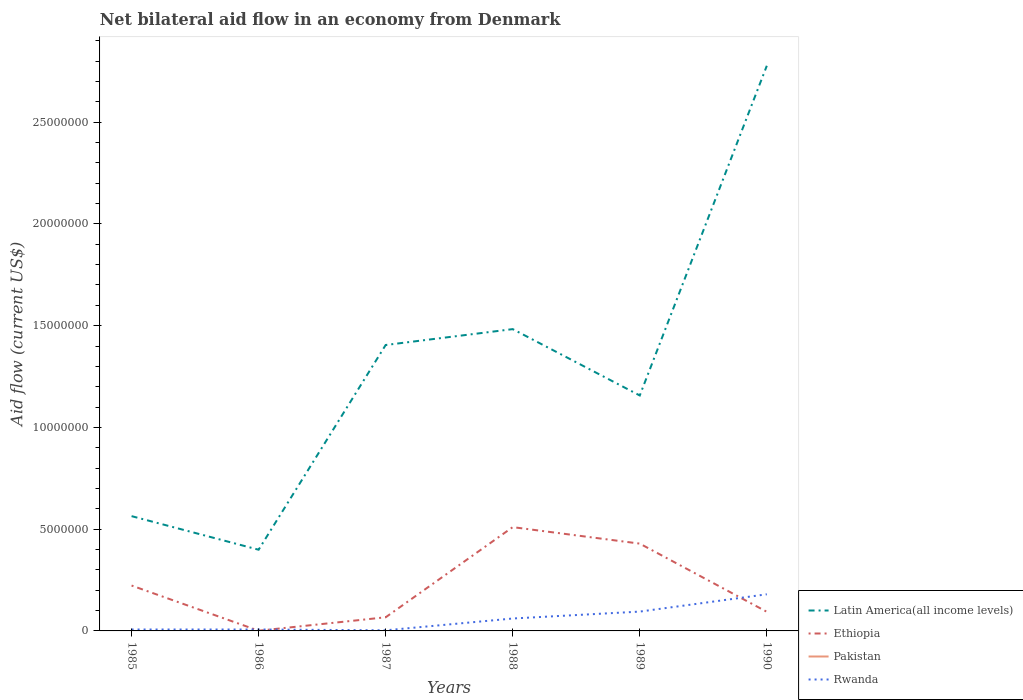How many different coloured lines are there?
Give a very brief answer. 3. Does the line corresponding to Pakistan intersect with the line corresponding to Latin America(all income levels)?
Your answer should be very brief. No. Is the number of lines equal to the number of legend labels?
Provide a short and direct response. No. Across all years, what is the maximum net bilateral aid flow in Pakistan?
Your response must be concise. 0. What is the total net bilateral aid flow in Latin America(all income levels) in the graph?
Provide a short and direct response. -1.29e+07. What is the difference between the highest and the second highest net bilateral aid flow in Rwanda?
Your answer should be compact. 1.77e+06. What is the difference between the highest and the lowest net bilateral aid flow in Rwanda?
Offer a terse response. 3. How many years are there in the graph?
Your answer should be compact. 6. Are the values on the major ticks of Y-axis written in scientific E-notation?
Offer a terse response. No. How are the legend labels stacked?
Make the answer very short. Vertical. What is the title of the graph?
Your response must be concise. Net bilateral aid flow in an economy from Denmark. Does "St. Lucia" appear as one of the legend labels in the graph?
Ensure brevity in your answer.  No. What is the Aid flow (current US$) of Latin America(all income levels) in 1985?
Make the answer very short. 5.64e+06. What is the Aid flow (current US$) in Ethiopia in 1985?
Your response must be concise. 2.23e+06. What is the Aid flow (current US$) of Rwanda in 1985?
Your response must be concise. 7.00e+04. What is the Aid flow (current US$) of Latin America(all income levels) in 1986?
Provide a succinct answer. 3.99e+06. What is the Aid flow (current US$) of Ethiopia in 1986?
Provide a short and direct response. 10000. What is the Aid flow (current US$) in Pakistan in 1986?
Offer a terse response. 0. What is the Aid flow (current US$) in Rwanda in 1986?
Keep it short and to the point. 7.00e+04. What is the Aid flow (current US$) of Latin America(all income levels) in 1987?
Offer a terse response. 1.40e+07. What is the Aid flow (current US$) in Ethiopia in 1987?
Provide a short and direct response. 6.70e+05. What is the Aid flow (current US$) of Rwanda in 1987?
Give a very brief answer. 3.00e+04. What is the Aid flow (current US$) of Latin America(all income levels) in 1988?
Your response must be concise. 1.48e+07. What is the Aid flow (current US$) in Ethiopia in 1988?
Offer a very short reply. 5.10e+06. What is the Aid flow (current US$) in Latin America(all income levels) in 1989?
Make the answer very short. 1.16e+07. What is the Aid flow (current US$) in Ethiopia in 1989?
Provide a short and direct response. 4.29e+06. What is the Aid flow (current US$) of Pakistan in 1989?
Provide a short and direct response. 0. What is the Aid flow (current US$) in Rwanda in 1989?
Offer a terse response. 9.50e+05. What is the Aid flow (current US$) of Latin America(all income levels) in 1990?
Make the answer very short. 2.78e+07. What is the Aid flow (current US$) of Ethiopia in 1990?
Keep it short and to the point. 9.40e+05. What is the Aid flow (current US$) of Pakistan in 1990?
Offer a very short reply. 0. What is the Aid flow (current US$) in Rwanda in 1990?
Your answer should be compact. 1.80e+06. Across all years, what is the maximum Aid flow (current US$) of Latin America(all income levels)?
Keep it short and to the point. 2.78e+07. Across all years, what is the maximum Aid flow (current US$) of Ethiopia?
Provide a succinct answer. 5.10e+06. Across all years, what is the maximum Aid flow (current US$) of Rwanda?
Give a very brief answer. 1.80e+06. Across all years, what is the minimum Aid flow (current US$) of Latin America(all income levels)?
Give a very brief answer. 3.99e+06. Across all years, what is the minimum Aid flow (current US$) in Ethiopia?
Make the answer very short. 10000. What is the total Aid flow (current US$) in Latin America(all income levels) in the graph?
Your response must be concise. 7.78e+07. What is the total Aid flow (current US$) of Ethiopia in the graph?
Make the answer very short. 1.32e+07. What is the total Aid flow (current US$) of Pakistan in the graph?
Offer a very short reply. 0. What is the total Aid flow (current US$) in Rwanda in the graph?
Keep it short and to the point. 3.53e+06. What is the difference between the Aid flow (current US$) of Latin America(all income levels) in 1985 and that in 1986?
Ensure brevity in your answer.  1.65e+06. What is the difference between the Aid flow (current US$) of Ethiopia in 1985 and that in 1986?
Keep it short and to the point. 2.22e+06. What is the difference between the Aid flow (current US$) in Rwanda in 1985 and that in 1986?
Provide a succinct answer. 0. What is the difference between the Aid flow (current US$) in Latin America(all income levels) in 1985 and that in 1987?
Your answer should be compact. -8.41e+06. What is the difference between the Aid flow (current US$) in Ethiopia in 1985 and that in 1987?
Your response must be concise. 1.56e+06. What is the difference between the Aid flow (current US$) in Rwanda in 1985 and that in 1987?
Your response must be concise. 4.00e+04. What is the difference between the Aid flow (current US$) of Latin America(all income levels) in 1985 and that in 1988?
Your answer should be compact. -9.19e+06. What is the difference between the Aid flow (current US$) in Ethiopia in 1985 and that in 1988?
Give a very brief answer. -2.87e+06. What is the difference between the Aid flow (current US$) in Rwanda in 1985 and that in 1988?
Make the answer very short. -5.40e+05. What is the difference between the Aid flow (current US$) in Latin America(all income levels) in 1985 and that in 1989?
Provide a short and direct response. -5.93e+06. What is the difference between the Aid flow (current US$) of Ethiopia in 1985 and that in 1989?
Your response must be concise. -2.06e+06. What is the difference between the Aid flow (current US$) of Rwanda in 1985 and that in 1989?
Ensure brevity in your answer.  -8.80e+05. What is the difference between the Aid flow (current US$) in Latin America(all income levels) in 1985 and that in 1990?
Provide a short and direct response. -2.21e+07. What is the difference between the Aid flow (current US$) in Ethiopia in 1985 and that in 1990?
Your answer should be very brief. 1.29e+06. What is the difference between the Aid flow (current US$) of Rwanda in 1985 and that in 1990?
Offer a terse response. -1.73e+06. What is the difference between the Aid flow (current US$) in Latin America(all income levels) in 1986 and that in 1987?
Make the answer very short. -1.01e+07. What is the difference between the Aid flow (current US$) of Ethiopia in 1986 and that in 1987?
Offer a very short reply. -6.60e+05. What is the difference between the Aid flow (current US$) of Latin America(all income levels) in 1986 and that in 1988?
Provide a succinct answer. -1.08e+07. What is the difference between the Aid flow (current US$) in Ethiopia in 1986 and that in 1988?
Provide a succinct answer. -5.09e+06. What is the difference between the Aid flow (current US$) of Rwanda in 1986 and that in 1988?
Your answer should be very brief. -5.40e+05. What is the difference between the Aid flow (current US$) in Latin America(all income levels) in 1986 and that in 1989?
Make the answer very short. -7.58e+06. What is the difference between the Aid flow (current US$) of Ethiopia in 1986 and that in 1989?
Make the answer very short. -4.28e+06. What is the difference between the Aid flow (current US$) in Rwanda in 1986 and that in 1989?
Keep it short and to the point. -8.80e+05. What is the difference between the Aid flow (current US$) of Latin America(all income levels) in 1986 and that in 1990?
Your answer should be very brief. -2.38e+07. What is the difference between the Aid flow (current US$) in Ethiopia in 1986 and that in 1990?
Your answer should be very brief. -9.30e+05. What is the difference between the Aid flow (current US$) in Rwanda in 1986 and that in 1990?
Give a very brief answer. -1.73e+06. What is the difference between the Aid flow (current US$) in Latin America(all income levels) in 1987 and that in 1988?
Offer a very short reply. -7.80e+05. What is the difference between the Aid flow (current US$) of Ethiopia in 1987 and that in 1988?
Keep it short and to the point. -4.43e+06. What is the difference between the Aid flow (current US$) in Rwanda in 1987 and that in 1988?
Your response must be concise. -5.80e+05. What is the difference between the Aid flow (current US$) of Latin America(all income levels) in 1987 and that in 1989?
Your answer should be very brief. 2.48e+06. What is the difference between the Aid flow (current US$) in Ethiopia in 1987 and that in 1989?
Keep it short and to the point. -3.62e+06. What is the difference between the Aid flow (current US$) of Rwanda in 1987 and that in 1989?
Your answer should be compact. -9.20e+05. What is the difference between the Aid flow (current US$) of Latin America(all income levels) in 1987 and that in 1990?
Provide a succinct answer. -1.37e+07. What is the difference between the Aid flow (current US$) in Rwanda in 1987 and that in 1990?
Make the answer very short. -1.77e+06. What is the difference between the Aid flow (current US$) in Latin America(all income levels) in 1988 and that in 1989?
Your answer should be very brief. 3.26e+06. What is the difference between the Aid flow (current US$) of Ethiopia in 1988 and that in 1989?
Provide a short and direct response. 8.10e+05. What is the difference between the Aid flow (current US$) of Latin America(all income levels) in 1988 and that in 1990?
Ensure brevity in your answer.  -1.29e+07. What is the difference between the Aid flow (current US$) in Ethiopia in 1988 and that in 1990?
Provide a succinct answer. 4.16e+06. What is the difference between the Aid flow (current US$) of Rwanda in 1988 and that in 1990?
Keep it short and to the point. -1.19e+06. What is the difference between the Aid flow (current US$) in Latin America(all income levels) in 1989 and that in 1990?
Keep it short and to the point. -1.62e+07. What is the difference between the Aid flow (current US$) in Ethiopia in 1989 and that in 1990?
Your answer should be compact. 3.35e+06. What is the difference between the Aid flow (current US$) in Rwanda in 1989 and that in 1990?
Make the answer very short. -8.50e+05. What is the difference between the Aid flow (current US$) of Latin America(all income levels) in 1985 and the Aid flow (current US$) of Ethiopia in 1986?
Make the answer very short. 5.63e+06. What is the difference between the Aid flow (current US$) of Latin America(all income levels) in 1985 and the Aid flow (current US$) of Rwanda in 1986?
Your answer should be compact. 5.57e+06. What is the difference between the Aid flow (current US$) of Ethiopia in 1985 and the Aid flow (current US$) of Rwanda in 1986?
Provide a succinct answer. 2.16e+06. What is the difference between the Aid flow (current US$) of Latin America(all income levels) in 1985 and the Aid flow (current US$) of Ethiopia in 1987?
Offer a very short reply. 4.97e+06. What is the difference between the Aid flow (current US$) in Latin America(all income levels) in 1985 and the Aid flow (current US$) in Rwanda in 1987?
Your answer should be very brief. 5.61e+06. What is the difference between the Aid flow (current US$) in Ethiopia in 1985 and the Aid flow (current US$) in Rwanda in 1987?
Offer a terse response. 2.20e+06. What is the difference between the Aid flow (current US$) of Latin America(all income levels) in 1985 and the Aid flow (current US$) of Ethiopia in 1988?
Offer a very short reply. 5.40e+05. What is the difference between the Aid flow (current US$) of Latin America(all income levels) in 1985 and the Aid flow (current US$) of Rwanda in 1988?
Provide a succinct answer. 5.03e+06. What is the difference between the Aid flow (current US$) of Ethiopia in 1985 and the Aid flow (current US$) of Rwanda in 1988?
Your response must be concise. 1.62e+06. What is the difference between the Aid flow (current US$) of Latin America(all income levels) in 1985 and the Aid flow (current US$) of Ethiopia in 1989?
Your response must be concise. 1.35e+06. What is the difference between the Aid flow (current US$) in Latin America(all income levels) in 1985 and the Aid flow (current US$) in Rwanda in 1989?
Offer a terse response. 4.69e+06. What is the difference between the Aid flow (current US$) in Ethiopia in 1985 and the Aid flow (current US$) in Rwanda in 1989?
Your response must be concise. 1.28e+06. What is the difference between the Aid flow (current US$) of Latin America(all income levels) in 1985 and the Aid flow (current US$) of Ethiopia in 1990?
Give a very brief answer. 4.70e+06. What is the difference between the Aid flow (current US$) of Latin America(all income levels) in 1985 and the Aid flow (current US$) of Rwanda in 1990?
Your answer should be very brief. 3.84e+06. What is the difference between the Aid flow (current US$) of Ethiopia in 1985 and the Aid flow (current US$) of Rwanda in 1990?
Make the answer very short. 4.30e+05. What is the difference between the Aid flow (current US$) of Latin America(all income levels) in 1986 and the Aid flow (current US$) of Ethiopia in 1987?
Your answer should be compact. 3.32e+06. What is the difference between the Aid flow (current US$) in Latin America(all income levels) in 1986 and the Aid flow (current US$) in Rwanda in 1987?
Your response must be concise. 3.96e+06. What is the difference between the Aid flow (current US$) in Latin America(all income levels) in 1986 and the Aid flow (current US$) in Ethiopia in 1988?
Offer a very short reply. -1.11e+06. What is the difference between the Aid flow (current US$) in Latin America(all income levels) in 1986 and the Aid flow (current US$) in Rwanda in 1988?
Offer a very short reply. 3.38e+06. What is the difference between the Aid flow (current US$) of Ethiopia in 1986 and the Aid flow (current US$) of Rwanda in 1988?
Give a very brief answer. -6.00e+05. What is the difference between the Aid flow (current US$) of Latin America(all income levels) in 1986 and the Aid flow (current US$) of Rwanda in 1989?
Provide a succinct answer. 3.04e+06. What is the difference between the Aid flow (current US$) of Ethiopia in 1986 and the Aid flow (current US$) of Rwanda in 1989?
Keep it short and to the point. -9.40e+05. What is the difference between the Aid flow (current US$) of Latin America(all income levels) in 1986 and the Aid flow (current US$) of Ethiopia in 1990?
Make the answer very short. 3.05e+06. What is the difference between the Aid flow (current US$) in Latin America(all income levels) in 1986 and the Aid flow (current US$) in Rwanda in 1990?
Your response must be concise. 2.19e+06. What is the difference between the Aid flow (current US$) of Ethiopia in 1986 and the Aid flow (current US$) of Rwanda in 1990?
Your answer should be compact. -1.79e+06. What is the difference between the Aid flow (current US$) in Latin America(all income levels) in 1987 and the Aid flow (current US$) in Ethiopia in 1988?
Provide a succinct answer. 8.95e+06. What is the difference between the Aid flow (current US$) of Latin America(all income levels) in 1987 and the Aid flow (current US$) of Rwanda in 1988?
Offer a very short reply. 1.34e+07. What is the difference between the Aid flow (current US$) of Latin America(all income levels) in 1987 and the Aid flow (current US$) of Ethiopia in 1989?
Keep it short and to the point. 9.76e+06. What is the difference between the Aid flow (current US$) in Latin America(all income levels) in 1987 and the Aid flow (current US$) in Rwanda in 1989?
Your answer should be compact. 1.31e+07. What is the difference between the Aid flow (current US$) in Ethiopia in 1987 and the Aid flow (current US$) in Rwanda in 1989?
Ensure brevity in your answer.  -2.80e+05. What is the difference between the Aid flow (current US$) in Latin America(all income levels) in 1987 and the Aid flow (current US$) in Ethiopia in 1990?
Keep it short and to the point. 1.31e+07. What is the difference between the Aid flow (current US$) in Latin America(all income levels) in 1987 and the Aid flow (current US$) in Rwanda in 1990?
Provide a short and direct response. 1.22e+07. What is the difference between the Aid flow (current US$) in Ethiopia in 1987 and the Aid flow (current US$) in Rwanda in 1990?
Provide a succinct answer. -1.13e+06. What is the difference between the Aid flow (current US$) of Latin America(all income levels) in 1988 and the Aid flow (current US$) of Ethiopia in 1989?
Your answer should be very brief. 1.05e+07. What is the difference between the Aid flow (current US$) in Latin America(all income levels) in 1988 and the Aid flow (current US$) in Rwanda in 1989?
Ensure brevity in your answer.  1.39e+07. What is the difference between the Aid flow (current US$) of Ethiopia in 1988 and the Aid flow (current US$) of Rwanda in 1989?
Your answer should be compact. 4.15e+06. What is the difference between the Aid flow (current US$) in Latin America(all income levels) in 1988 and the Aid flow (current US$) in Ethiopia in 1990?
Make the answer very short. 1.39e+07. What is the difference between the Aid flow (current US$) of Latin America(all income levels) in 1988 and the Aid flow (current US$) of Rwanda in 1990?
Provide a short and direct response. 1.30e+07. What is the difference between the Aid flow (current US$) in Ethiopia in 1988 and the Aid flow (current US$) in Rwanda in 1990?
Offer a very short reply. 3.30e+06. What is the difference between the Aid flow (current US$) of Latin America(all income levels) in 1989 and the Aid flow (current US$) of Ethiopia in 1990?
Ensure brevity in your answer.  1.06e+07. What is the difference between the Aid flow (current US$) of Latin America(all income levels) in 1989 and the Aid flow (current US$) of Rwanda in 1990?
Provide a short and direct response. 9.77e+06. What is the difference between the Aid flow (current US$) of Ethiopia in 1989 and the Aid flow (current US$) of Rwanda in 1990?
Offer a very short reply. 2.49e+06. What is the average Aid flow (current US$) in Latin America(all income levels) per year?
Offer a terse response. 1.30e+07. What is the average Aid flow (current US$) in Ethiopia per year?
Give a very brief answer. 2.21e+06. What is the average Aid flow (current US$) of Rwanda per year?
Offer a terse response. 5.88e+05. In the year 1985, what is the difference between the Aid flow (current US$) of Latin America(all income levels) and Aid flow (current US$) of Ethiopia?
Your answer should be compact. 3.41e+06. In the year 1985, what is the difference between the Aid flow (current US$) in Latin America(all income levels) and Aid flow (current US$) in Rwanda?
Your response must be concise. 5.57e+06. In the year 1985, what is the difference between the Aid flow (current US$) of Ethiopia and Aid flow (current US$) of Rwanda?
Your answer should be compact. 2.16e+06. In the year 1986, what is the difference between the Aid flow (current US$) in Latin America(all income levels) and Aid flow (current US$) in Ethiopia?
Your answer should be very brief. 3.98e+06. In the year 1986, what is the difference between the Aid flow (current US$) in Latin America(all income levels) and Aid flow (current US$) in Rwanda?
Provide a succinct answer. 3.92e+06. In the year 1987, what is the difference between the Aid flow (current US$) in Latin America(all income levels) and Aid flow (current US$) in Ethiopia?
Your answer should be compact. 1.34e+07. In the year 1987, what is the difference between the Aid flow (current US$) of Latin America(all income levels) and Aid flow (current US$) of Rwanda?
Offer a terse response. 1.40e+07. In the year 1987, what is the difference between the Aid flow (current US$) in Ethiopia and Aid flow (current US$) in Rwanda?
Keep it short and to the point. 6.40e+05. In the year 1988, what is the difference between the Aid flow (current US$) in Latin America(all income levels) and Aid flow (current US$) in Ethiopia?
Your response must be concise. 9.73e+06. In the year 1988, what is the difference between the Aid flow (current US$) in Latin America(all income levels) and Aid flow (current US$) in Rwanda?
Offer a very short reply. 1.42e+07. In the year 1988, what is the difference between the Aid flow (current US$) of Ethiopia and Aid flow (current US$) of Rwanda?
Give a very brief answer. 4.49e+06. In the year 1989, what is the difference between the Aid flow (current US$) of Latin America(all income levels) and Aid flow (current US$) of Ethiopia?
Provide a succinct answer. 7.28e+06. In the year 1989, what is the difference between the Aid flow (current US$) in Latin America(all income levels) and Aid flow (current US$) in Rwanda?
Provide a succinct answer. 1.06e+07. In the year 1989, what is the difference between the Aid flow (current US$) in Ethiopia and Aid flow (current US$) in Rwanda?
Your answer should be very brief. 3.34e+06. In the year 1990, what is the difference between the Aid flow (current US$) of Latin America(all income levels) and Aid flow (current US$) of Ethiopia?
Ensure brevity in your answer.  2.68e+07. In the year 1990, what is the difference between the Aid flow (current US$) of Latin America(all income levels) and Aid flow (current US$) of Rwanda?
Offer a very short reply. 2.60e+07. In the year 1990, what is the difference between the Aid flow (current US$) of Ethiopia and Aid flow (current US$) of Rwanda?
Keep it short and to the point. -8.60e+05. What is the ratio of the Aid flow (current US$) in Latin America(all income levels) in 1985 to that in 1986?
Keep it short and to the point. 1.41. What is the ratio of the Aid flow (current US$) of Ethiopia in 1985 to that in 1986?
Provide a succinct answer. 223. What is the ratio of the Aid flow (current US$) in Latin America(all income levels) in 1985 to that in 1987?
Provide a short and direct response. 0.4. What is the ratio of the Aid flow (current US$) of Ethiopia in 1985 to that in 1987?
Your answer should be compact. 3.33. What is the ratio of the Aid flow (current US$) in Rwanda in 1985 to that in 1987?
Make the answer very short. 2.33. What is the ratio of the Aid flow (current US$) in Latin America(all income levels) in 1985 to that in 1988?
Provide a short and direct response. 0.38. What is the ratio of the Aid flow (current US$) of Ethiopia in 1985 to that in 1988?
Provide a succinct answer. 0.44. What is the ratio of the Aid flow (current US$) of Rwanda in 1985 to that in 1988?
Make the answer very short. 0.11. What is the ratio of the Aid flow (current US$) in Latin America(all income levels) in 1985 to that in 1989?
Your response must be concise. 0.49. What is the ratio of the Aid flow (current US$) of Ethiopia in 1985 to that in 1989?
Ensure brevity in your answer.  0.52. What is the ratio of the Aid flow (current US$) in Rwanda in 1985 to that in 1989?
Give a very brief answer. 0.07. What is the ratio of the Aid flow (current US$) in Latin America(all income levels) in 1985 to that in 1990?
Provide a short and direct response. 0.2. What is the ratio of the Aid flow (current US$) in Ethiopia in 1985 to that in 1990?
Provide a short and direct response. 2.37. What is the ratio of the Aid flow (current US$) in Rwanda in 1985 to that in 1990?
Provide a succinct answer. 0.04. What is the ratio of the Aid flow (current US$) of Latin America(all income levels) in 1986 to that in 1987?
Your answer should be very brief. 0.28. What is the ratio of the Aid flow (current US$) of Ethiopia in 1986 to that in 1987?
Your answer should be compact. 0.01. What is the ratio of the Aid flow (current US$) of Rwanda in 1986 to that in 1987?
Provide a short and direct response. 2.33. What is the ratio of the Aid flow (current US$) of Latin America(all income levels) in 1986 to that in 1988?
Make the answer very short. 0.27. What is the ratio of the Aid flow (current US$) of Ethiopia in 1986 to that in 1988?
Your answer should be very brief. 0. What is the ratio of the Aid flow (current US$) in Rwanda in 1986 to that in 1988?
Offer a terse response. 0.11. What is the ratio of the Aid flow (current US$) in Latin America(all income levels) in 1986 to that in 1989?
Offer a very short reply. 0.34. What is the ratio of the Aid flow (current US$) in Ethiopia in 1986 to that in 1989?
Provide a short and direct response. 0. What is the ratio of the Aid flow (current US$) in Rwanda in 1986 to that in 1989?
Make the answer very short. 0.07. What is the ratio of the Aid flow (current US$) of Latin America(all income levels) in 1986 to that in 1990?
Provide a succinct answer. 0.14. What is the ratio of the Aid flow (current US$) in Ethiopia in 1986 to that in 1990?
Give a very brief answer. 0.01. What is the ratio of the Aid flow (current US$) in Rwanda in 1986 to that in 1990?
Your answer should be very brief. 0.04. What is the ratio of the Aid flow (current US$) of Ethiopia in 1987 to that in 1988?
Give a very brief answer. 0.13. What is the ratio of the Aid flow (current US$) in Rwanda in 1987 to that in 1988?
Keep it short and to the point. 0.05. What is the ratio of the Aid flow (current US$) of Latin America(all income levels) in 1987 to that in 1989?
Give a very brief answer. 1.21. What is the ratio of the Aid flow (current US$) of Ethiopia in 1987 to that in 1989?
Give a very brief answer. 0.16. What is the ratio of the Aid flow (current US$) of Rwanda in 1987 to that in 1989?
Ensure brevity in your answer.  0.03. What is the ratio of the Aid flow (current US$) of Latin America(all income levels) in 1987 to that in 1990?
Keep it short and to the point. 0.51. What is the ratio of the Aid flow (current US$) of Ethiopia in 1987 to that in 1990?
Your response must be concise. 0.71. What is the ratio of the Aid flow (current US$) of Rwanda in 1987 to that in 1990?
Provide a short and direct response. 0.02. What is the ratio of the Aid flow (current US$) of Latin America(all income levels) in 1988 to that in 1989?
Give a very brief answer. 1.28. What is the ratio of the Aid flow (current US$) in Ethiopia in 1988 to that in 1989?
Provide a short and direct response. 1.19. What is the ratio of the Aid flow (current US$) of Rwanda in 1988 to that in 1989?
Provide a succinct answer. 0.64. What is the ratio of the Aid flow (current US$) in Latin America(all income levels) in 1988 to that in 1990?
Make the answer very short. 0.53. What is the ratio of the Aid flow (current US$) in Ethiopia in 1988 to that in 1990?
Your answer should be compact. 5.43. What is the ratio of the Aid flow (current US$) of Rwanda in 1988 to that in 1990?
Ensure brevity in your answer.  0.34. What is the ratio of the Aid flow (current US$) in Latin America(all income levels) in 1989 to that in 1990?
Provide a short and direct response. 0.42. What is the ratio of the Aid flow (current US$) of Ethiopia in 1989 to that in 1990?
Provide a short and direct response. 4.56. What is the ratio of the Aid flow (current US$) of Rwanda in 1989 to that in 1990?
Provide a succinct answer. 0.53. What is the difference between the highest and the second highest Aid flow (current US$) in Latin America(all income levels)?
Ensure brevity in your answer.  1.29e+07. What is the difference between the highest and the second highest Aid flow (current US$) in Ethiopia?
Your response must be concise. 8.10e+05. What is the difference between the highest and the second highest Aid flow (current US$) of Rwanda?
Offer a terse response. 8.50e+05. What is the difference between the highest and the lowest Aid flow (current US$) of Latin America(all income levels)?
Offer a terse response. 2.38e+07. What is the difference between the highest and the lowest Aid flow (current US$) in Ethiopia?
Ensure brevity in your answer.  5.09e+06. What is the difference between the highest and the lowest Aid flow (current US$) in Rwanda?
Your answer should be compact. 1.77e+06. 